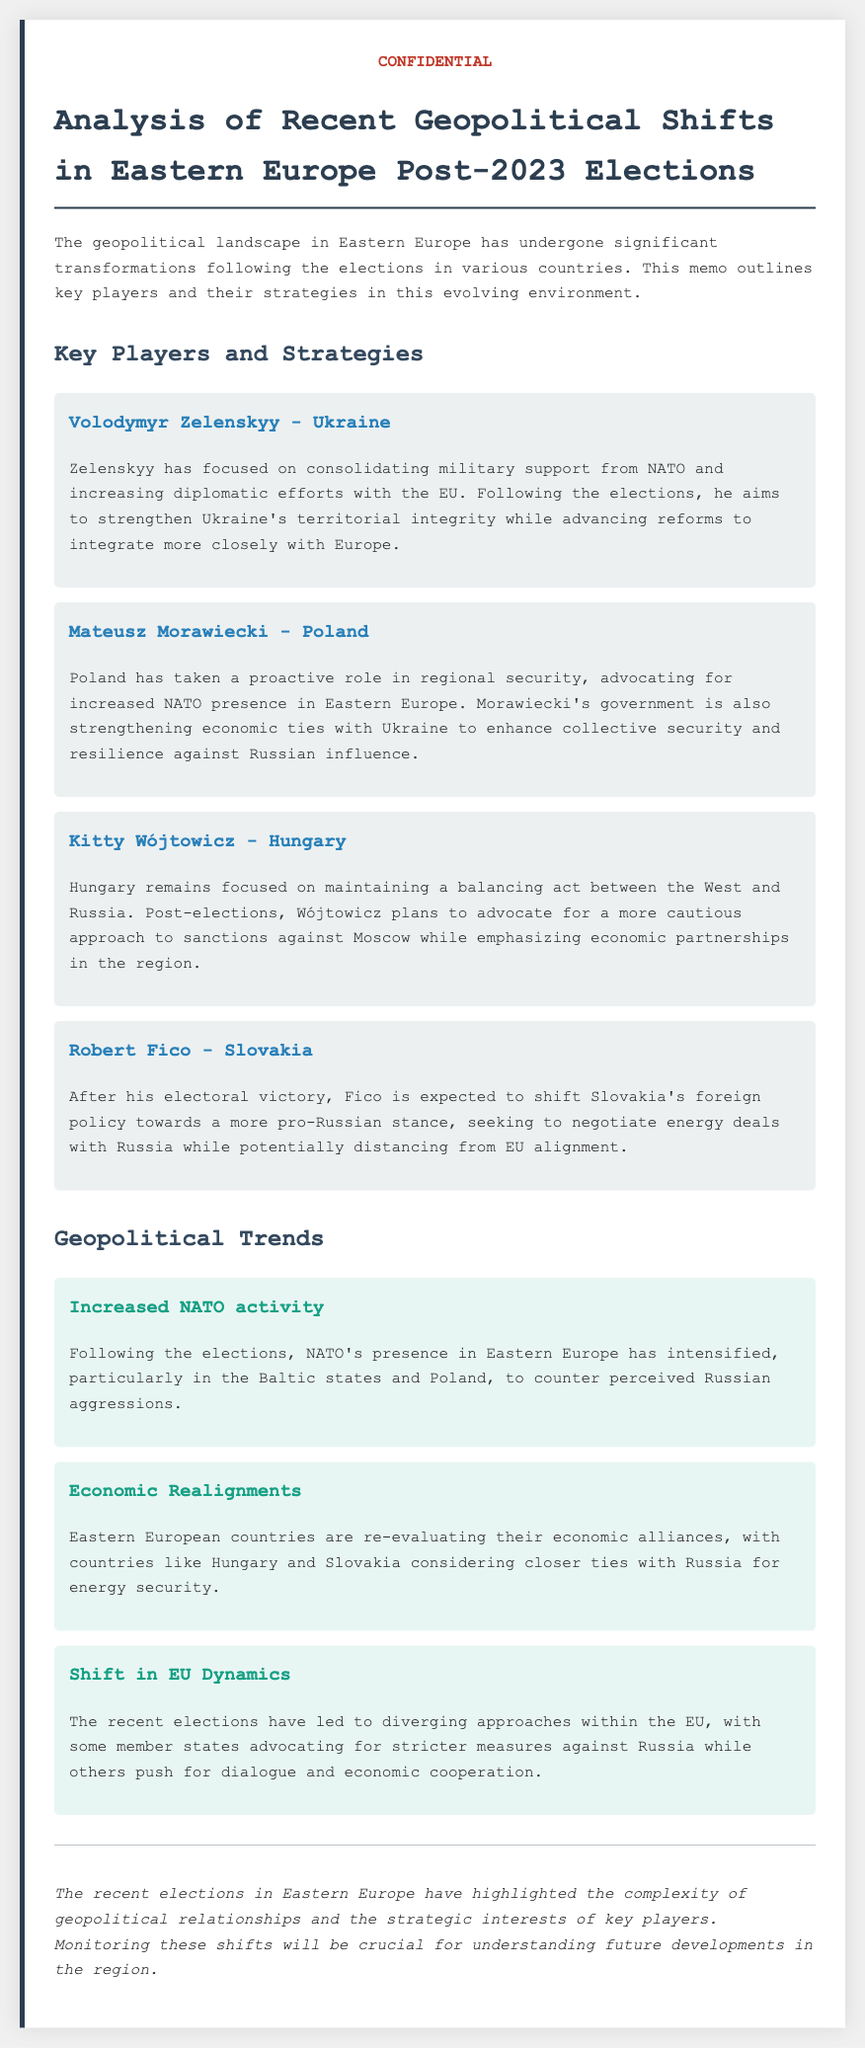What is the main focus of Volodymyr Zelenskyy? Zelenskyy's main focus is on consolidating military support from NATO and increasing diplomatic efforts with the EU.
Answer: Military support and EU diplomacy What is Mateusz Morawiecki advocating for? Morawiecki is advocating for increased NATO presence in Eastern Europe.
Answer: Increased NATO presence What strategy is Kitty Wójtowicz planning to implement after the elections? Wójtowicz plans to advocate for a more cautious approach to sanctions against Moscow.
Answer: Cautious approach to sanctions What foreign policy shift is Robert Fico expected to make? Fico is expected to shift Slovakia's foreign policy towards a more pro-Russian stance.
Answer: Pro-Russian stance How has NATO's activity changed post-elections? NATO's presence in Eastern Europe has intensified, particularly in the Baltic states and Poland.
Answer: Intensified presence What economic realignment is noted in Hungary and Slovakia? Hungary and Slovakia are considering closer ties with Russia for energy security.
Answer: Closer ties with Russia What divergence in EU approaches is highlighted? Some member states advocate for stricter measures against Russia while others push for dialogue.
Answer: Stricter measures vs dialogue What is emphasized in the conclusion of the memo? The conclusion emphasizes the complexity of geopolitical relationships and the strategic interests of key players.
Answer: Complexity of geopolitical relationships 